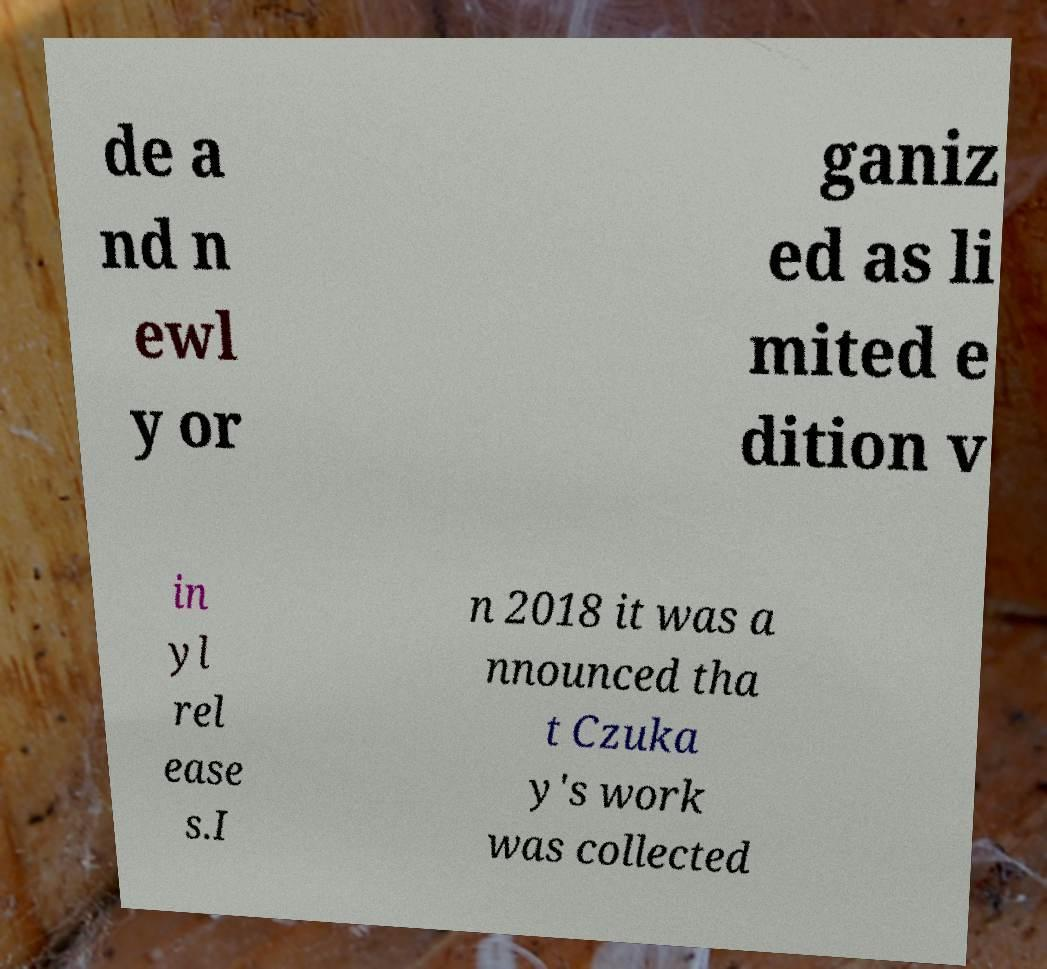There's text embedded in this image that I need extracted. Can you transcribe it verbatim? de a nd n ewl y or ganiz ed as li mited e dition v in yl rel ease s.I n 2018 it was a nnounced tha t Czuka y's work was collected 